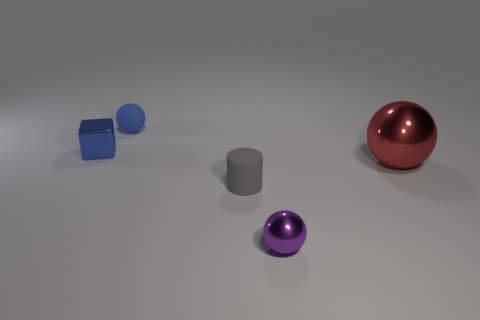The metal thing that is on the left side of the matte cylinder right of the matte ball is what color?
Keep it short and to the point. Blue. Does the small shiny ball have the same color as the sphere that is left of the cylinder?
Offer a very short reply. No. There is a purple thing that is made of the same material as the red ball; what size is it?
Give a very brief answer. Small. There is a ball that is the same color as the shiny cube; what size is it?
Keep it short and to the point. Small. Does the tiny metal ball have the same color as the small block?
Offer a very short reply. No. There is a rubber thing on the right side of the object behind the cube; are there any small blue rubber things to the left of it?
Make the answer very short. Yes. What number of objects have the same size as the metal cube?
Offer a terse response. 3. Do the shiny ball on the left side of the big sphere and the object behind the blue shiny cube have the same size?
Your response must be concise. Yes. What shape is the object that is in front of the small metal cube and left of the small shiny ball?
Provide a succinct answer. Cylinder. Is there a small ball of the same color as the big thing?
Your answer should be compact. No. 